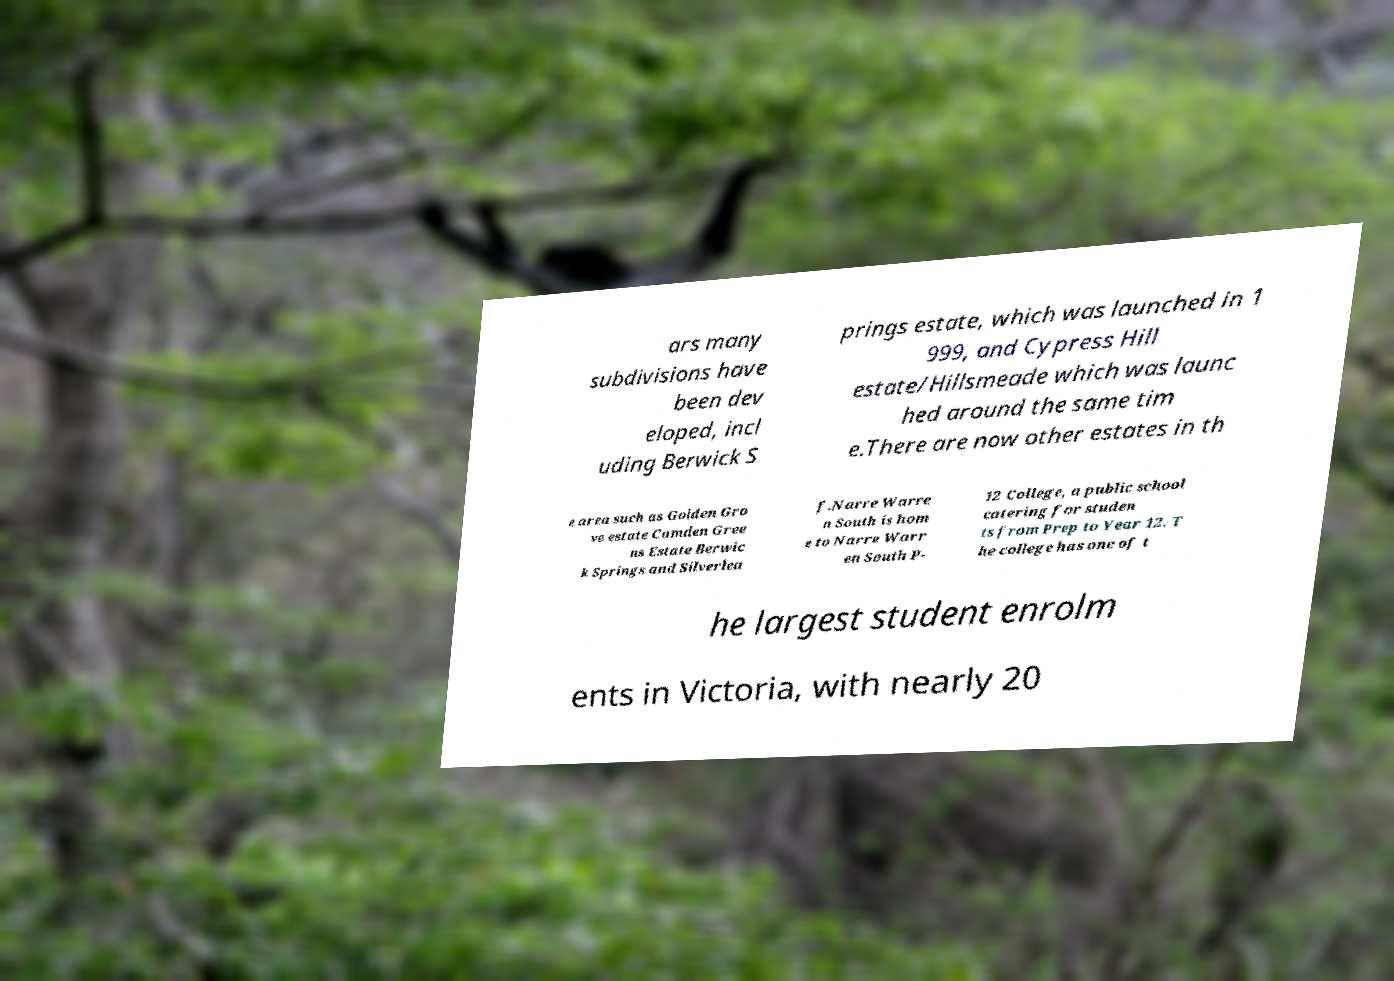There's text embedded in this image that I need extracted. Can you transcribe it verbatim? ars many subdivisions have been dev eloped, incl uding Berwick S prings estate, which was launched in 1 999, and Cypress Hill estate/Hillsmeade which was launc hed around the same tim e.There are now other estates in th e area such as Golden Gro ve estate Camden Gree ns Estate Berwic k Springs and Silverlea f.Narre Warre n South is hom e to Narre Warr en South P- 12 College, a public school catering for studen ts from Prep to Year 12. T he college has one of t he largest student enrolm ents in Victoria, with nearly 20 